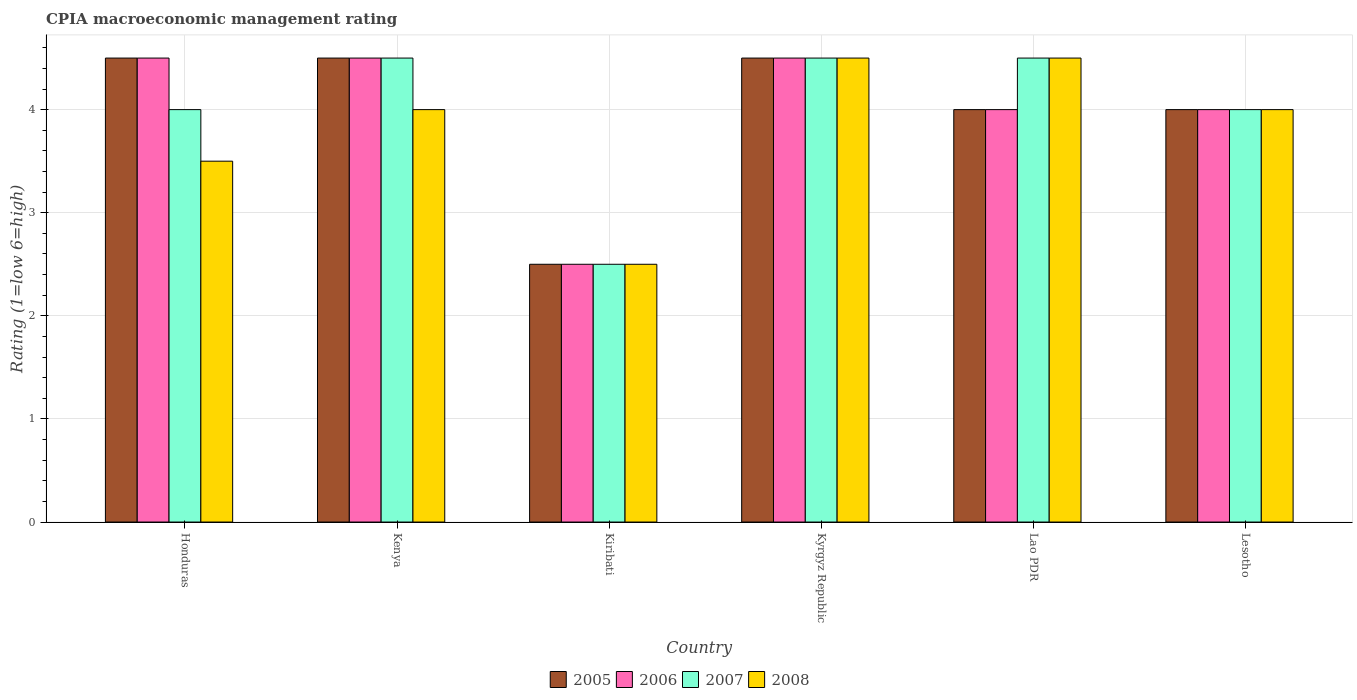How many different coloured bars are there?
Give a very brief answer. 4. Are the number of bars per tick equal to the number of legend labels?
Give a very brief answer. Yes. How many bars are there on the 4th tick from the right?
Your answer should be very brief. 4. What is the label of the 3rd group of bars from the left?
Your response must be concise. Kiribati. What is the CPIA rating in 2005 in Lesotho?
Your answer should be very brief. 4. Across all countries, what is the minimum CPIA rating in 2008?
Ensure brevity in your answer.  2.5. In which country was the CPIA rating in 2006 maximum?
Provide a succinct answer. Honduras. In which country was the CPIA rating in 2005 minimum?
Your answer should be very brief. Kiribati. What is the difference between the CPIA rating in 2008 in Kiribati and that in Kyrgyz Republic?
Provide a short and direct response. -2. What is the average CPIA rating in 2008 per country?
Your response must be concise. 3.83. What is the ratio of the CPIA rating in 2007 in Honduras to that in Kyrgyz Republic?
Make the answer very short. 0.89. Is the CPIA rating in 2005 in Honduras less than that in Kyrgyz Republic?
Make the answer very short. No. Is the sum of the CPIA rating in 2006 in Kiribati and Lesotho greater than the maximum CPIA rating in 2008 across all countries?
Make the answer very short. Yes. What does the 1st bar from the left in Kenya represents?
Offer a terse response. 2005. What does the 2nd bar from the right in Kenya represents?
Keep it short and to the point. 2007. Are the values on the major ticks of Y-axis written in scientific E-notation?
Your response must be concise. No. Does the graph contain any zero values?
Your response must be concise. No. Does the graph contain grids?
Your response must be concise. Yes. What is the title of the graph?
Your answer should be compact. CPIA macroeconomic management rating. Does "1960" appear as one of the legend labels in the graph?
Give a very brief answer. No. What is the Rating (1=low 6=high) in 2007 in Honduras?
Your response must be concise. 4. What is the Rating (1=low 6=high) in 2008 in Honduras?
Provide a succinct answer. 3.5. What is the Rating (1=low 6=high) of 2006 in Kenya?
Your answer should be very brief. 4.5. What is the Rating (1=low 6=high) of 2007 in Kenya?
Offer a terse response. 4.5. What is the Rating (1=low 6=high) in 2008 in Kenya?
Ensure brevity in your answer.  4. What is the Rating (1=low 6=high) of 2006 in Kiribati?
Provide a short and direct response. 2.5. What is the Rating (1=low 6=high) in 2007 in Kiribati?
Keep it short and to the point. 2.5. What is the Rating (1=low 6=high) of 2005 in Kyrgyz Republic?
Ensure brevity in your answer.  4.5. What is the Rating (1=low 6=high) in 2008 in Kyrgyz Republic?
Make the answer very short. 4.5. What is the Rating (1=low 6=high) in 2005 in Lao PDR?
Your response must be concise. 4. What is the Rating (1=low 6=high) of 2006 in Lao PDR?
Make the answer very short. 4. What is the Rating (1=low 6=high) in 2005 in Lesotho?
Provide a short and direct response. 4. What is the Rating (1=low 6=high) of 2008 in Lesotho?
Ensure brevity in your answer.  4. Across all countries, what is the maximum Rating (1=low 6=high) in 2006?
Provide a short and direct response. 4.5. Across all countries, what is the maximum Rating (1=low 6=high) of 2007?
Your answer should be very brief. 4.5. Across all countries, what is the maximum Rating (1=low 6=high) of 2008?
Provide a succinct answer. 4.5. Across all countries, what is the minimum Rating (1=low 6=high) in 2008?
Provide a succinct answer. 2.5. What is the total Rating (1=low 6=high) in 2005 in the graph?
Make the answer very short. 24. What is the total Rating (1=low 6=high) in 2006 in the graph?
Give a very brief answer. 24. What is the difference between the Rating (1=low 6=high) of 2005 in Honduras and that in Kenya?
Your response must be concise. 0. What is the difference between the Rating (1=low 6=high) of 2006 in Honduras and that in Kenya?
Provide a short and direct response. 0. What is the difference between the Rating (1=low 6=high) of 2007 in Honduras and that in Kenya?
Keep it short and to the point. -0.5. What is the difference between the Rating (1=low 6=high) in 2008 in Honduras and that in Kenya?
Keep it short and to the point. -0.5. What is the difference between the Rating (1=low 6=high) of 2005 in Honduras and that in Kiribati?
Provide a short and direct response. 2. What is the difference between the Rating (1=low 6=high) of 2006 in Honduras and that in Kiribati?
Make the answer very short. 2. What is the difference between the Rating (1=low 6=high) in 2007 in Honduras and that in Kiribati?
Ensure brevity in your answer.  1.5. What is the difference between the Rating (1=low 6=high) of 2008 in Honduras and that in Kiribati?
Ensure brevity in your answer.  1. What is the difference between the Rating (1=low 6=high) of 2005 in Honduras and that in Kyrgyz Republic?
Provide a succinct answer. 0. What is the difference between the Rating (1=low 6=high) in 2006 in Honduras and that in Kyrgyz Republic?
Offer a very short reply. 0. What is the difference between the Rating (1=low 6=high) of 2005 in Honduras and that in Lao PDR?
Make the answer very short. 0.5. What is the difference between the Rating (1=low 6=high) in 2007 in Honduras and that in Lao PDR?
Provide a short and direct response. -0.5. What is the difference between the Rating (1=low 6=high) in 2007 in Honduras and that in Lesotho?
Offer a very short reply. 0. What is the difference between the Rating (1=low 6=high) in 2005 in Kenya and that in Lao PDR?
Your response must be concise. 0.5. What is the difference between the Rating (1=low 6=high) in 2006 in Kenya and that in Lao PDR?
Offer a very short reply. 0.5. What is the difference between the Rating (1=low 6=high) of 2008 in Kenya and that in Lao PDR?
Your response must be concise. -0.5. What is the difference between the Rating (1=low 6=high) in 2005 in Kenya and that in Lesotho?
Make the answer very short. 0.5. What is the difference between the Rating (1=low 6=high) of 2007 in Kenya and that in Lesotho?
Make the answer very short. 0.5. What is the difference between the Rating (1=low 6=high) of 2006 in Kiribati and that in Kyrgyz Republic?
Your answer should be very brief. -2. What is the difference between the Rating (1=low 6=high) in 2007 in Kiribati and that in Kyrgyz Republic?
Provide a short and direct response. -2. What is the difference between the Rating (1=low 6=high) of 2005 in Kiribati and that in Lao PDR?
Offer a very short reply. -1.5. What is the difference between the Rating (1=low 6=high) of 2006 in Kiribati and that in Lao PDR?
Make the answer very short. -1.5. What is the difference between the Rating (1=low 6=high) of 2007 in Kiribati and that in Lao PDR?
Make the answer very short. -2. What is the difference between the Rating (1=low 6=high) in 2008 in Kiribati and that in Lao PDR?
Provide a succinct answer. -2. What is the difference between the Rating (1=low 6=high) in 2006 in Kiribati and that in Lesotho?
Make the answer very short. -1.5. What is the difference between the Rating (1=low 6=high) in 2006 in Kyrgyz Republic and that in Lao PDR?
Your answer should be compact. 0.5. What is the difference between the Rating (1=low 6=high) of 2007 in Kyrgyz Republic and that in Lao PDR?
Your response must be concise. 0. What is the difference between the Rating (1=low 6=high) of 2005 in Kyrgyz Republic and that in Lesotho?
Ensure brevity in your answer.  0.5. What is the difference between the Rating (1=low 6=high) of 2006 in Kyrgyz Republic and that in Lesotho?
Ensure brevity in your answer.  0.5. What is the difference between the Rating (1=low 6=high) of 2007 in Kyrgyz Republic and that in Lesotho?
Your response must be concise. 0.5. What is the difference between the Rating (1=low 6=high) in 2008 in Kyrgyz Republic and that in Lesotho?
Provide a succinct answer. 0.5. What is the difference between the Rating (1=low 6=high) of 2005 in Lao PDR and that in Lesotho?
Your answer should be compact. 0. What is the difference between the Rating (1=low 6=high) in 2006 in Lao PDR and that in Lesotho?
Give a very brief answer. 0. What is the difference between the Rating (1=low 6=high) in 2007 in Lao PDR and that in Lesotho?
Give a very brief answer. 0.5. What is the difference between the Rating (1=low 6=high) in 2005 in Honduras and the Rating (1=low 6=high) in 2006 in Kenya?
Offer a very short reply. 0. What is the difference between the Rating (1=low 6=high) in 2005 in Honduras and the Rating (1=low 6=high) in 2007 in Kenya?
Provide a succinct answer. 0. What is the difference between the Rating (1=low 6=high) in 2005 in Honduras and the Rating (1=low 6=high) in 2008 in Kenya?
Give a very brief answer. 0.5. What is the difference between the Rating (1=low 6=high) in 2006 in Honduras and the Rating (1=low 6=high) in 2007 in Kenya?
Keep it short and to the point. 0. What is the difference between the Rating (1=low 6=high) in 2005 in Honduras and the Rating (1=low 6=high) in 2007 in Kiribati?
Provide a short and direct response. 2. What is the difference between the Rating (1=low 6=high) in 2005 in Honduras and the Rating (1=low 6=high) in 2008 in Kiribati?
Your answer should be compact. 2. What is the difference between the Rating (1=low 6=high) of 2006 in Honduras and the Rating (1=low 6=high) of 2008 in Kiribati?
Offer a terse response. 2. What is the difference between the Rating (1=low 6=high) in 2005 in Honduras and the Rating (1=low 6=high) in 2006 in Kyrgyz Republic?
Offer a terse response. 0. What is the difference between the Rating (1=low 6=high) in 2005 in Honduras and the Rating (1=low 6=high) in 2007 in Kyrgyz Republic?
Provide a succinct answer. 0. What is the difference between the Rating (1=low 6=high) in 2006 in Honduras and the Rating (1=low 6=high) in 2007 in Kyrgyz Republic?
Ensure brevity in your answer.  0. What is the difference between the Rating (1=low 6=high) in 2005 in Honduras and the Rating (1=low 6=high) in 2006 in Lao PDR?
Offer a terse response. 0.5. What is the difference between the Rating (1=low 6=high) of 2005 in Honduras and the Rating (1=low 6=high) of 2007 in Lao PDR?
Give a very brief answer. 0. What is the difference between the Rating (1=low 6=high) of 2006 in Honduras and the Rating (1=low 6=high) of 2008 in Lao PDR?
Provide a short and direct response. 0. What is the difference between the Rating (1=low 6=high) in 2007 in Honduras and the Rating (1=low 6=high) in 2008 in Lao PDR?
Offer a very short reply. -0.5. What is the difference between the Rating (1=low 6=high) in 2005 in Honduras and the Rating (1=low 6=high) in 2006 in Lesotho?
Offer a very short reply. 0.5. What is the difference between the Rating (1=low 6=high) in 2005 in Honduras and the Rating (1=low 6=high) in 2007 in Lesotho?
Keep it short and to the point. 0.5. What is the difference between the Rating (1=low 6=high) of 2006 in Honduras and the Rating (1=low 6=high) of 2007 in Lesotho?
Provide a succinct answer. 0.5. What is the difference between the Rating (1=low 6=high) of 2006 in Honduras and the Rating (1=low 6=high) of 2008 in Lesotho?
Offer a very short reply. 0.5. What is the difference between the Rating (1=low 6=high) of 2005 in Kenya and the Rating (1=low 6=high) of 2006 in Kyrgyz Republic?
Provide a succinct answer. 0. What is the difference between the Rating (1=low 6=high) of 2005 in Kenya and the Rating (1=low 6=high) of 2007 in Kyrgyz Republic?
Your answer should be very brief. 0. What is the difference between the Rating (1=low 6=high) of 2006 in Kenya and the Rating (1=low 6=high) of 2008 in Kyrgyz Republic?
Make the answer very short. 0. What is the difference between the Rating (1=low 6=high) of 2005 in Kenya and the Rating (1=low 6=high) of 2006 in Lao PDR?
Your answer should be very brief. 0.5. What is the difference between the Rating (1=low 6=high) of 2005 in Kenya and the Rating (1=low 6=high) of 2007 in Lao PDR?
Keep it short and to the point. 0. What is the difference between the Rating (1=low 6=high) in 2005 in Kenya and the Rating (1=low 6=high) in 2008 in Lao PDR?
Give a very brief answer. 0. What is the difference between the Rating (1=low 6=high) in 2005 in Kenya and the Rating (1=low 6=high) in 2007 in Lesotho?
Give a very brief answer. 0.5. What is the difference between the Rating (1=low 6=high) of 2005 in Kenya and the Rating (1=low 6=high) of 2008 in Lesotho?
Make the answer very short. 0.5. What is the difference between the Rating (1=low 6=high) in 2006 in Kenya and the Rating (1=low 6=high) in 2007 in Lesotho?
Provide a short and direct response. 0.5. What is the difference between the Rating (1=low 6=high) in 2006 in Kenya and the Rating (1=low 6=high) in 2008 in Lesotho?
Your answer should be compact. 0.5. What is the difference between the Rating (1=low 6=high) of 2007 in Kenya and the Rating (1=low 6=high) of 2008 in Lesotho?
Provide a short and direct response. 0.5. What is the difference between the Rating (1=low 6=high) of 2005 in Kiribati and the Rating (1=low 6=high) of 2007 in Kyrgyz Republic?
Your response must be concise. -2. What is the difference between the Rating (1=low 6=high) of 2005 in Kiribati and the Rating (1=low 6=high) of 2008 in Kyrgyz Republic?
Give a very brief answer. -2. What is the difference between the Rating (1=low 6=high) of 2006 in Kiribati and the Rating (1=low 6=high) of 2007 in Kyrgyz Republic?
Provide a short and direct response. -2. What is the difference between the Rating (1=low 6=high) of 2006 in Kiribati and the Rating (1=low 6=high) of 2008 in Kyrgyz Republic?
Give a very brief answer. -2. What is the difference between the Rating (1=low 6=high) in 2007 in Kiribati and the Rating (1=low 6=high) in 2008 in Kyrgyz Republic?
Keep it short and to the point. -2. What is the difference between the Rating (1=low 6=high) in 2005 in Kiribati and the Rating (1=low 6=high) in 2006 in Lao PDR?
Your answer should be very brief. -1.5. What is the difference between the Rating (1=low 6=high) in 2005 in Kiribati and the Rating (1=low 6=high) in 2007 in Lao PDR?
Ensure brevity in your answer.  -2. What is the difference between the Rating (1=low 6=high) in 2005 in Kiribati and the Rating (1=low 6=high) in 2008 in Lao PDR?
Give a very brief answer. -2. What is the difference between the Rating (1=low 6=high) of 2006 in Kiribati and the Rating (1=low 6=high) of 2008 in Lao PDR?
Provide a succinct answer. -2. What is the difference between the Rating (1=low 6=high) of 2007 in Kiribati and the Rating (1=low 6=high) of 2008 in Lao PDR?
Your answer should be compact. -2. What is the difference between the Rating (1=low 6=high) of 2005 in Kiribati and the Rating (1=low 6=high) of 2006 in Lesotho?
Offer a very short reply. -1.5. What is the difference between the Rating (1=low 6=high) in 2006 in Kiribati and the Rating (1=low 6=high) in 2008 in Lesotho?
Offer a terse response. -1.5. What is the difference between the Rating (1=low 6=high) of 2007 in Kiribati and the Rating (1=low 6=high) of 2008 in Lesotho?
Give a very brief answer. -1.5. What is the difference between the Rating (1=low 6=high) in 2005 in Kyrgyz Republic and the Rating (1=low 6=high) in 2008 in Lao PDR?
Offer a very short reply. 0. What is the difference between the Rating (1=low 6=high) in 2006 in Kyrgyz Republic and the Rating (1=low 6=high) in 2007 in Lao PDR?
Your response must be concise. 0. What is the difference between the Rating (1=low 6=high) in 2007 in Kyrgyz Republic and the Rating (1=low 6=high) in 2008 in Lao PDR?
Provide a succinct answer. 0. What is the difference between the Rating (1=low 6=high) of 2005 in Kyrgyz Republic and the Rating (1=low 6=high) of 2006 in Lesotho?
Offer a very short reply. 0.5. What is the difference between the Rating (1=low 6=high) of 2005 in Kyrgyz Republic and the Rating (1=low 6=high) of 2007 in Lesotho?
Ensure brevity in your answer.  0.5. What is the difference between the Rating (1=low 6=high) of 2005 in Kyrgyz Republic and the Rating (1=low 6=high) of 2008 in Lesotho?
Provide a short and direct response. 0.5. What is the difference between the Rating (1=low 6=high) in 2005 in Lao PDR and the Rating (1=low 6=high) in 2006 in Lesotho?
Your answer should be very brief. 0. What is the difference between the Rating (1=low 6=high) of 2005 in Lao PDR and the Rating (1=low 6=high) of 2008 in Lesotho?
Give a very brief answer. 0. What is the difference between the Rating (1=low 6=high) in 2006 in Lao PDR and the Rating (1=low 6=high) in 2007 in Lesotho?
Your answer should be compact. 0. What is the difference between the Rating (1=low 6=high) of 2006 in Lao PDR and the Rating (1=low 6=high) of 2008 in Lesotho?
Keep it short and to the point. 0. What is the difference between the Rating (1=low 6=high) in 2007 in Lao PDR and the Rating (1=low 6=high) in 2008 in Lesotho?
Your answer should be compact. 0.5. What is the average Rating (1=low 6=high) in 2005 per country?
Provide a succinct answer. 4. What is the average Rating (1=low 6=high) of 2008 per country?
Your response must be concise. 3.83. What is the difference between the Rating (1=low 6=high) in 2005 and Rating (1=low 6=high) in 2006 in Honduras?
Your answer should be compact. 0. What is the difference between the Rating (1=low 6=high) of 2005 and Rating (1=low 6=high) of 2007 in Honduras?
Give a very brief answer. 0.5. What is the difference between the Rating (1=low 6=high) in 2005 and Rating (1=low 6=high) in 2008 in Honduras?
Provide a short and direct response. 1. What is the difference between the Rating (1=low 6=high) in 2006 and Rating (1=low 6=high) in 2007 in Honduras?
Make the answer very short. 0.5. What is the difference between the Rating (1=low 6=high) of 2006 and Rating (1=low 6=high) of 2008 in Honduras?
Provide a succinct answer. 1. What is the difference between the Rating (1=low 6=high) of 2005 and Rating (1=low 6=high) of 2006 in Kenya?
Give a very brief answer. 0. What is the difference between the Rating (1=low 6=high) in 2005 and Rating (1=low 6=high) in 2007 in Kenya?
Your answer should be very brief. 0. What is the difference between the Rating (1=low 6=high) in 2005 and Rating (1=low 6=high) in 2008 in Kenya?
Ensure brevity in your answer.  0.5. What is the difference between the Rating (1=low 6=high) in 2006 and Rating (1=low 6=high) in 2008 in Kenya?
Offer a terse response. 0.5. What is the difference between the Rating (1=low 6=high) of 2005 and Rating (1=low 6=high) of 2006 in Kiribati?
Offer a very short reply. 0. What is the difference between the Rating (1=low 6=high) in 2005 and Rating (1=low 6=high) in 2008 in Kiribati?
Ensure brevity in your answer.  0. What is the difference between the Rating (1=low 6=high) in 2006 and Rating (1=low 6=high) in 2008 in Kiribati?
Offer a very short reply. 0. What is the difference between the Rating (1=low 6=high) in 2005 and Rating (1=low 6=high) in 2006 in Kyrgyz Republic?
Offer a terse response. 0. What is the difference between the Rating (1=low 6=high) of 2005 and Rating (1=low 6=high) of 2007 in Kyrgyz Republic?
Your answer should be compact. 0. What is the difference between the Rating (1=low 6=high) in 2005 and Rating (1=low 6=high) in 2008 in Kyrgyz Republic?
Make the answer very short. 0. What is the difference between the Rating (1=low 6=high) in 2006 and Rating (1=low 6=high) in 2007 in Kyrgyz Republic?
Provide a succinct answer. 0. What is the difference between the Rating (1=low 6=high) in 2007 and Rating (1=low 6=high) in 2008 in Kyrgyz Republic?
Your response must be concise. 0. What is the difference between the Rating (1=low 6=high) in 2005 and Rating (1=low 6=high) in 2006 in Lao PDR?
Offer a very short reply. 0. What is the difference between the Rating (1=low 6=high) in 2006 and Rating (1=low 6=high) in 2007 in Lao PDR?
Ensure brevity in your answer.  -0.5. What is the difference between the Rating (1=low 6=high) of 2005 and Rating (1=low 6=high) of 2007 in Lesotho?
Keep it short and to the point. 0. What is the difference between the Rating (1=low 6=high) of 2005 and Rating (1=low 6=high) of 2008 in Lesotho?
Offer a terse response. 0. What is the difference between the Rating (1=low 6=high) of 2006 and Rating (1=low 6=high) of 2008 in Lesotho?
Give a very brief answer. 0. What is the ratio of the Rating (1=low 6=high) in 2006 in Honduras to that in Kenya?
Your answer should be very brief. 1. What is the ratio of the Rating (1=low 6=high) in 2007 in Honduras to that in Kenya?
Provide a short and direct response. 0.89. What is the ratio of the Rating (1=low 6=high) in 2008 in Honduras to that in Kenya?
Provide a succinct answer. 0.88. What is the ratio of the Rating (1=low 6=high) in 2005 in Honduras to that in Kiribati?
Offer a terse response. 1.8. What is the ratio of the Rating (1=low 6=high) of 2006 in Honduras to that in Kiribati?
Your answer should be very brief. 1.8. What is the ratio of the Rating (1=low 6=high) in 2007 in Honduras to that in Kiribati?
Your response must be concise. 1.6. What is the ratio of the Rating (1=low 6=high) in 2008 in Honduras to that in Kiribati?
Give a very brief answer. 1.4. What is the ratio of the Rating (1=low 6=high) of 2006 in Honduras to that in Kyrgyz Republic?
Your response must be concise. 1. What is the ratio of the Rating (1=low 6=high) of 2008 in Honduras to that in Kyrgyz Republic?
Offer a very short reply. 0.78. What is the ratio of the Rating (1=low 6=high) in 2006 in Honduras to that in Lesotho?
Make the answer very short. 1.12. What is the ratio of the Rating (1=low 6=high) of 2007 in Honduras to that in Lesotho?
Provide a short and direct response. 1. What is the ratio of the Rating (1=low 6=high) in 2008 in Honduras to that in Lesotho?
Provide a short and direct response. 0.88. What is the ratio of the Rating (1=low 6=high) in 2006 in Kenya to that in Kiribati?
Give a very brief answer. 1.8. What is the ratio of the Rating (1=low 6=high) of 2006 in Kenya to that in Kyrgyz Republic?
Offer a terse response. 1. What is the ratio of the Rating (1=low 6=high) in 2006 in Kenya to that in Lesotho?
Offer a terse response. 1.12. What is the ratio of the Rating (1=low 6=high) in 2008 in Kenya to that in Lesotho?
Your answer should be compact. 1. What is the ratio of the Rating (1=low 6=high) in 2005 in Kiribati to that in Kyrgyz Republic?
Provide a succinct answer. 0.56. What is the ratio of the Rating (1=low 6=high) in 2006 in Kiribati to that in Kyrgyz Republic?
Your answer should be compact. 0.56. What is the ratio of the Rating (1=low 6=high) in 2007 in Kiribati to that in Kyrgyz Republic?
Give a very brief answer. 0.56. What is the ratio of the Rating (1=low 6=high) in 2008 in Kiribati to that in Kyrgyz Republic?
Offer a very short reply. 0.56. What is the ratio of the Rating (1=low 6=high) of 2007 in Kiribati to that in Lao PDR?
Provide a succinct answer. 0.56. What is the ratio of the Rating (1=low 6=high) in 2008 in Kiribati to that in Lao PDR?
Your answer should be compact. 0.56. What is the ratio of the Rating (1=low 6=high) of 2008 in Kiribati to that in Lesotho?
Your response must be concise. 0.62. What is the ratio of the Rating (1=low 6=high) in 2006 in Kyrgyz Republic to that in Lesotho?
Your answer should be compact. 1.12. What is the ratio of the Rating (1=low 6=high) of 2007 in Kyrgyz Republic to that in Lesotho?
Give a very brief answer. 1.12. What is the ratio of the Rating (1=low 6=high) in 2005 in Lao PDR to that in Lesotho?
Offer a very short reply. 1. What is the ratio of the Rating (1=low 6=high) of 2006 in Lao PDR to that in Lesotho?
Make the answer very short. 1. What is the difference between the highest and the second highest Rating (1=low 6=high) in 2006?
Keep it short and to the point. 0. What is the difference between the highest and the second highest Rating (1=low 6=high) of 2007?
Your answer should be very brief. 0. What is the difference between the highest and the lowest Rating (1=low 6=high) in 2005?
Provide a succinct answer. 2. 